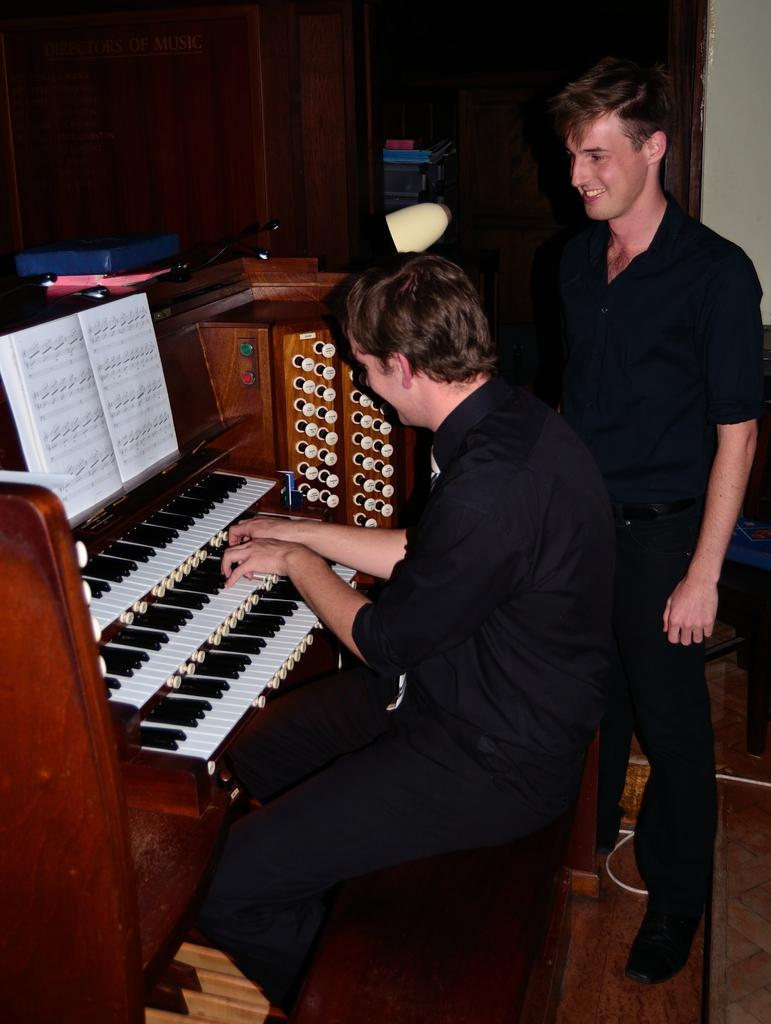What is present in the image that serves as a background? There is a wall in the image that serves as a background. What is the main subject of the image? The main subject of the image is a man. What is the man doing in the image? The man is playing a musical keyboard in the image. How many cherries are on the musical keyboard in the image? There are no cherries present on the musical keyboard in the image. What type of plants can be seen growing on the wall in the image? There are no plants visible on the wall in the image. 